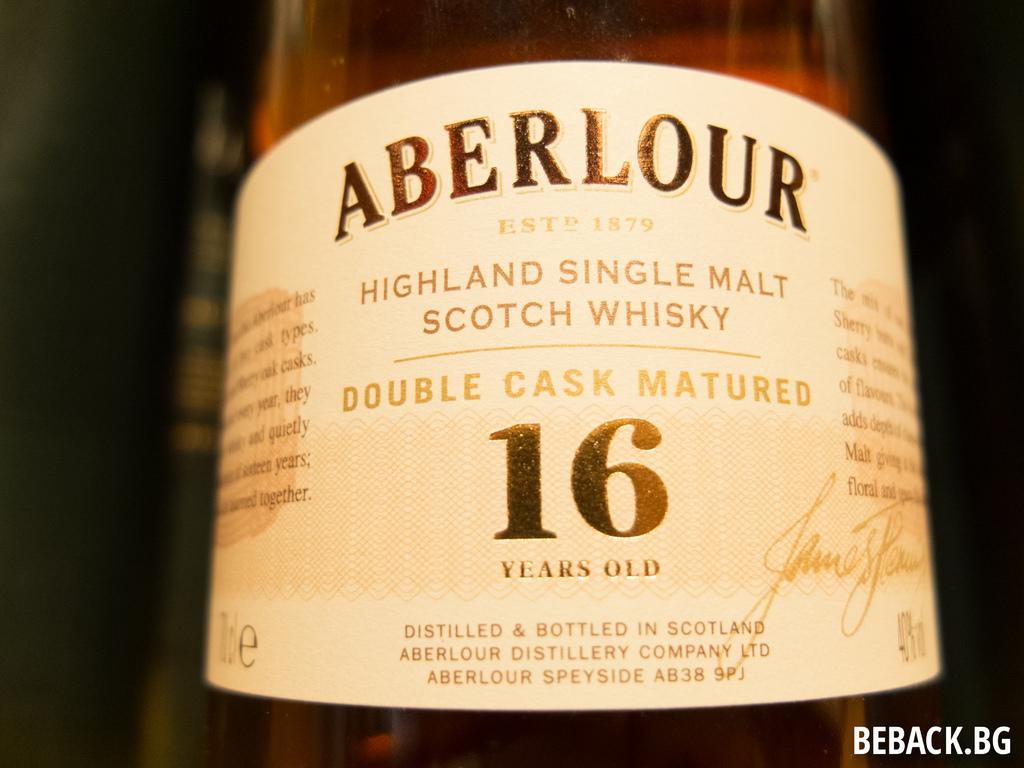How old is this scotch?
Your answer should be very brief. 16. Whats the scotchtype?
Provide a short and direct response. Highland single malt. 